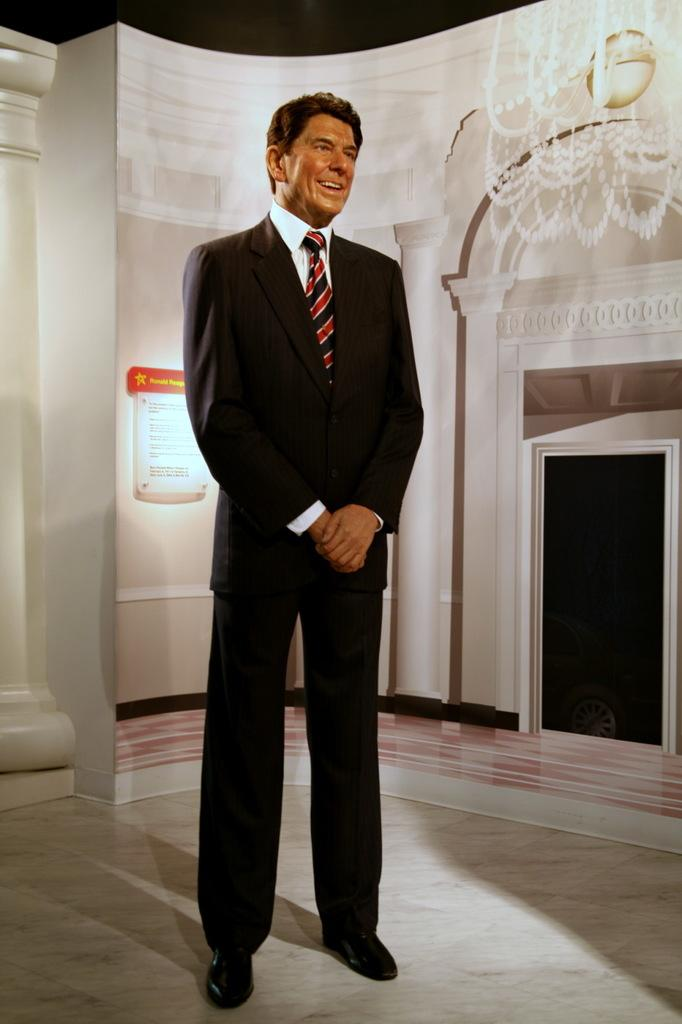What is the main subject of the image? There is a person standing in the image. What can be seen on the wall in the image? There is a wall with wallpaper in the image. Are there any architectural features in the image? Yes, there is a pillar in the image. What is hanging on the wallpaper? There is a chandelier on the wallpaper. How many daughters does the person in the image have? There is no information about the person's daughters in the image. Can you see any bees flying around the chandelier in the image? There are no bees present in the image. 